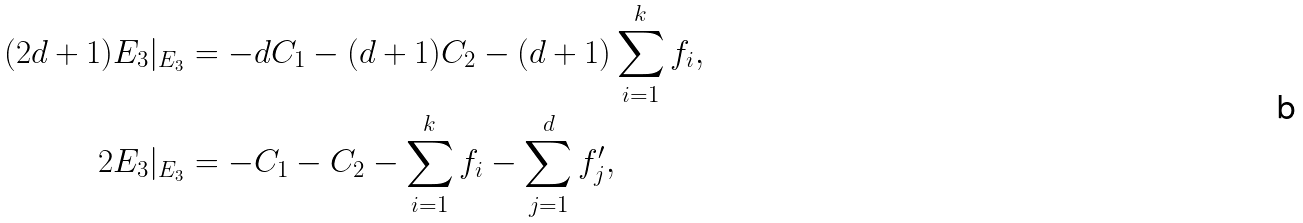<formula> <loc_0><loc_0><loc_500><loc_500>( 2 d + 1 ) E _ { 3 } | _ { E _ { 3 } } & = - d C _ { 1 } - ( d + 1 ) C _ { 2 } - ( d + 1 ) \sum _ { i = 1 } ^ { k } f _ { i } , \\ 2 E _ { 3 } | _ { E _ { 3 } } & = - C _ { 1 } - C _ { 2 } - \sum _ { i = 1 } ^ { k } f _ { i } - \sum _ { j = 1 } ^ { d } f _ { j } ^ { \prime } ,</formula> 